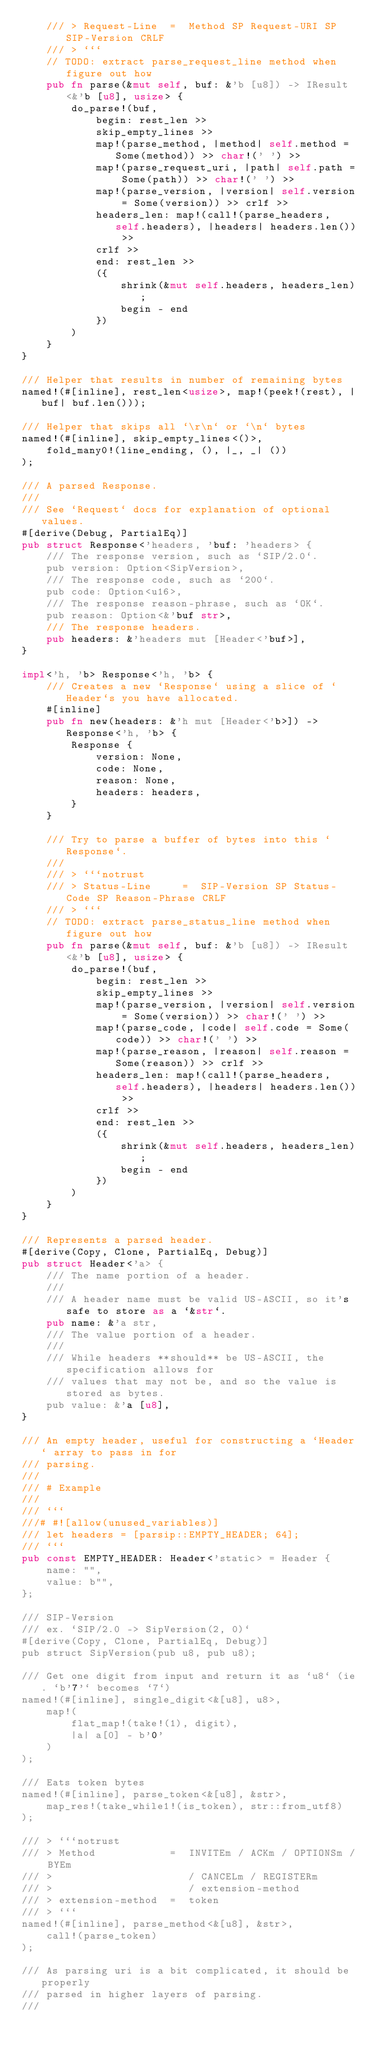Convert code to text. <code><loc_0><loc_0><loc_500><loc_500><_Rust_>    /// > Request-Line  =  Method SP Request-URI SP SIP-Version CRLF
    /// > ```
    // TODO: extract parse_request_line method when figure out how
    pub fn parse(&mut self, buf: &'b [u8]) -> IResult<&'b [u8], usize> {
        do_parse!(buf,
            begin: rest_len >>
            skip_empty_lines >>
            map!(parse_method, |method| self.method = Some(method)) >> char!(' ') >>
            map!(parse_request_uri, |path| self.path = Some(path)) >> char!(' ') >>
            map!(parse_version, |version| self.version = Some(version)) >> crlf >>
            headers_len: map!(call!(parse_headers, self.headers), |headers| headers.len()) >>
            crlf >>
            end: rest_len >>
            ({
                shrink(&mut self.headers, headers_len);
                begin - end
            })
        )
    }
}

/// Helper that results in number of remaining bytes
named!(#[inline], rest_len<usize>, map!(peek!(rest), |buf| buf.len()));

/// Helper that skips all `\r\n` or `\n` bytes
named!(#[inline], skip_empty_lines<()>,
    fold_many0!(line_ending, (), |_, _| ())
);

/// A parsed Response.
///
/// See `Request` docs for explanation of optional values.
#[derive(Debug, PartialEq)]
pub struct Response<'headers, 'buf: 'headers> {
    /// The response version, such as `SIP/2.0`.
    pub version: Option<SipVersion>,
    /// The response code, such as `200`.
    pub code: Option<u16>,
    /// The response reason-phrase, such as `OK`.
    pub reason: Option<&'buf str>,
    /// The response headers.
    pub headers: &'headers mut [Header<'buf>],
}

impl<'h, 'b> Response<'h, 'b> {
    /// Creates a new `Response` using a slice of `Header`s you have allocated.
    #[inline]
    pub fn new(headers: &'h mut [Header<'b>]) -> Response<'h, 'b> {
        Response {
            version: None,
            code: None,
            reason: None,
            headers: headers,
        }
    }

    /// Try to parse a buffer of bytes into this `Response`.
    ///
    /// > ```notrust
    /// > Status-Line     =  SIP-Version SP Status-Code SP Reason-Phrase CRLF
    /// > ```
    // TODO: extract parse_status_line method when figure out how
    pub fn parse(&mut self, buf: &'b [u8]) -> IResult<&'b [u8], usize> {
        do_parse!(buf,
            begin: rest_len >>
            skip_empty_lines >>
            map!(parse_version, |version| self.version = Some(version)) >> char!(' ') >>
            map!(parse_code, |code| self.code = Some(code)) >> char!(' ') >>
            map!(parse_reason, |reason| self.reason = Some(reason)) >> crlf >>
            headers_len: map!(call!(parse_headers, self.headers), |headers| headers.len()) >>
            crlf >>
            end: rest_len >>
            ({
                shrink(&mut self.headers, headers_len);
                begin - end
            })
        )
    }
}

/// Represents a parsed header.
#[derive(Copy, Clone, PartialEq, Debug)]
pub struct Header<'a> {
    /// The name portion of a header.
    ///
    /// A header name must be valid US-ASCII, so it's safe to store as a `&str`.
    pub name: &'a str,
    /// The value portion of a header.
    ///
    /// While headers **should** be US-ASCII, the specification allows for
    /// values that may not be, and so the value is stored as bytes.
    pub value: &'a [u8],
}

/// An empty header, useful for constructing a `Header` array to pass in for
/// parsing.
///
/// # Example
///
/// ```
///# #![allow(unused_variables)]
/// let headers = [parsip::EMPTY_HEADER; 64];
/// ```
pub const EMPTY_HEADER: Header<'static> = Header {
    name: "",
    value: b"",
};

/// SIP-Version
/// ex. `SIP/2.0 -> SipVersion(2, 0)`
#[derive(Copy, Clone, PartialEq, Debug)]
pub struct SipVersion(pub u8, pub u8);

/// Get one digit from input and return it as `u8` (ie. `b'7'` becomes `7`)
named!(#[inline], single_digit<&[u8], u8>,
    map!(
        flat_map!(take!(1), digit),
        |a| a[0] - b'0'
    )
);

/// Eats token bytes
named!(#[inline], parse_token<&[u8], &str>,
    map_res!(take_while1!(is_token), str::from_utf8)
);

/// > ```notrust
/// > Method            =  INVITEm / ACKm / OPTIONSm / BYEm
/// >                      / CANCELm / REGISTERm
/// >                      / extension-method
/// > extension-method  =  token
/// > ```
named!(#[inline], parse_method<&[u8], &str>,
    call!(parse_token)
);

/// As parsing uri is a bit complicated, it should be properly
/// parsed in higher layers of parsing.
///</code> 